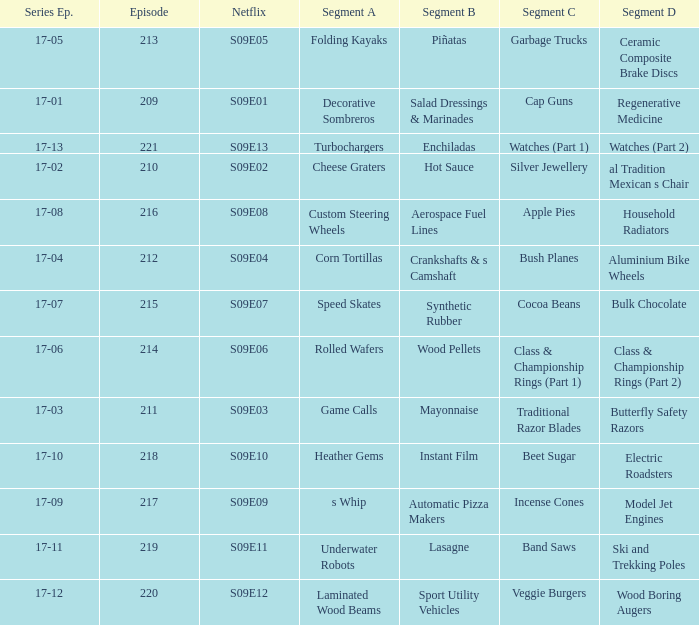Episode smaller than 210 had what segment c? Cap Guns. 